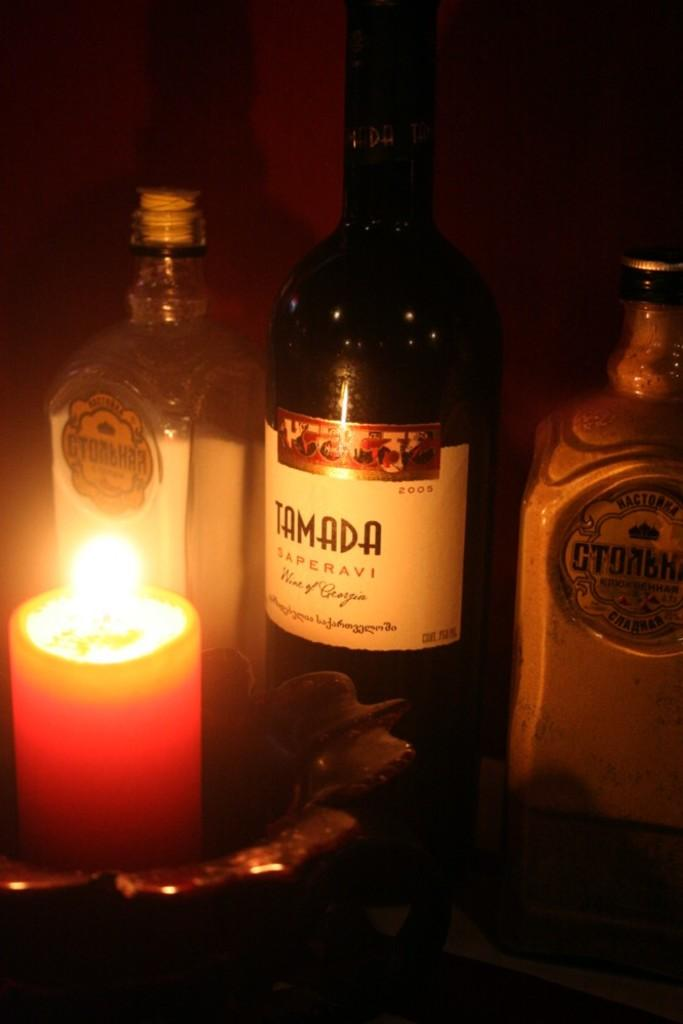<image>
Provide a brief description of the given image. "TAMADA" is written on a white bottle label. 